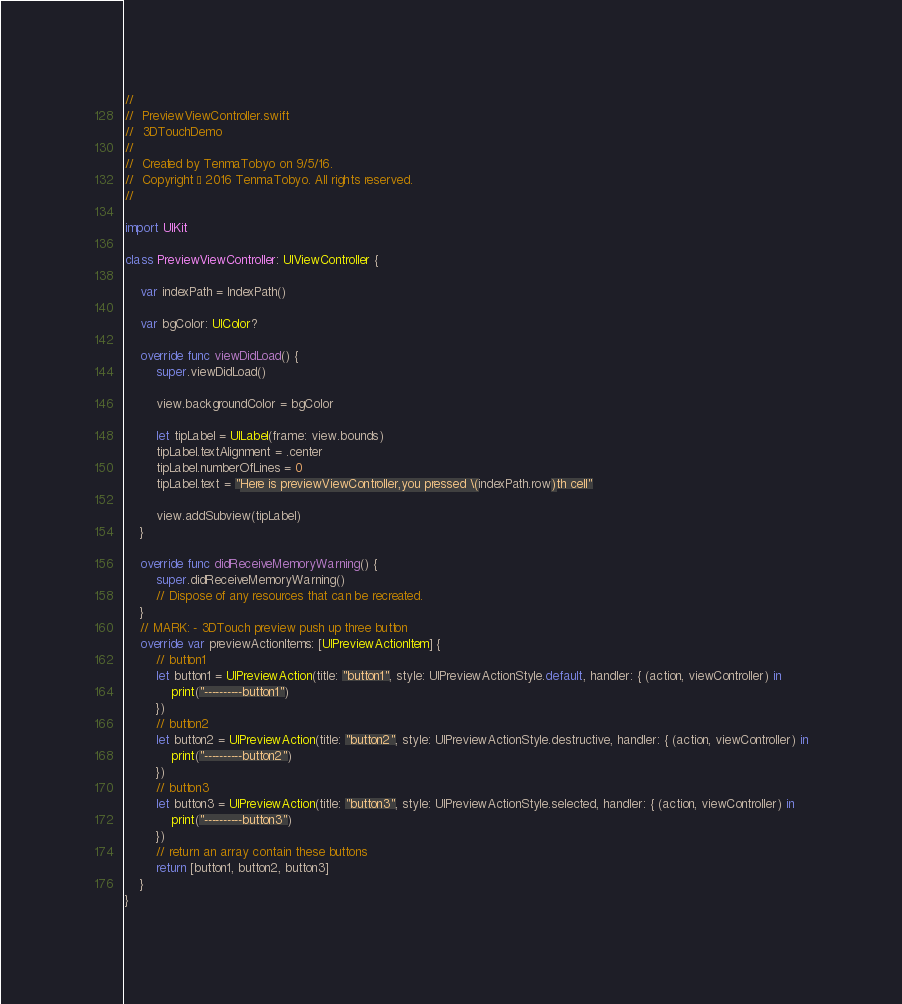<code> <loc_0><loc_0><loc_500><loc_500><_Swift_>//
//  PreviewViewController.swift
//  3DTouchDemo
//
//  Created by TenmaTobyo on 9/5/16.
//  Copyright © 2016 TenmaTobyo. All rights reserved.
//

import UIKit

class PreviewViewController: UIViewController {
    
    var indexPath = IndexPath()
    
    var bgColor: UIColor?

    override func viewDidLoad() {
        super.viewDidLoad()

        view.backgroundColor = bgColor
        
        let tipLabel = UILabel(frame: view.bounds)
        tipLabel.textAlignment = .center
        tipLabel.numberOfLines = 0
        tipLabel.text = "Here is previewViewController,you pressed \(indexPath.row)th cell"
        
        view.addSubview(tipLabel)
    }

    override func didReceiveMemoryWarning() {
        super.didReceiveMemoryWarning()
        // Dispose of any resources that can be recreated.
    }
    // MARK: - 3DTouch preview push up three button
    override var previewActionItems: [UIPreviewActionItem] {
        // button1
        let button1 = UIPreviewAction(title: "button1", style: UIPreviewActionStyle.default, handler: { (action, viewController) in
            print("----------button1")
        })
        // button2
        let button2 = UIPreviewAction(title: "button2", style: UIPreviewActionStyle.destructive, handler: { (action, viewController) in
            print("----------button2")
        })
        // button3
        let button3 = UIPreviewAction(title: "button3", style: UIPreviewActionStyle.selected, handler: { (action, viewController) in
            print("----------button3")
        })
        // return an array contain these buttons
        return [button1, button2, button3]
    }
}
</code> 